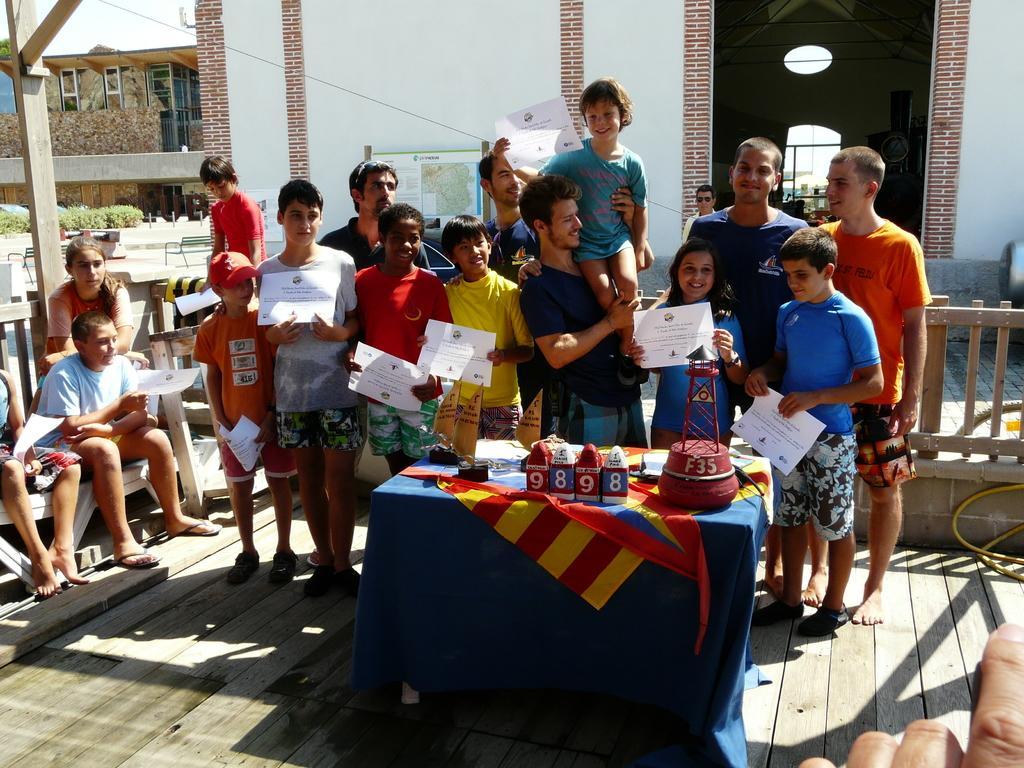Please provide a concise description of this image. There is a group of people. They are showing papers. In front of them, there is a table. These persons are standing on wooden floor. On the left hand side, there are people. They are sitting. In the background, there is a wall, building and sky. 